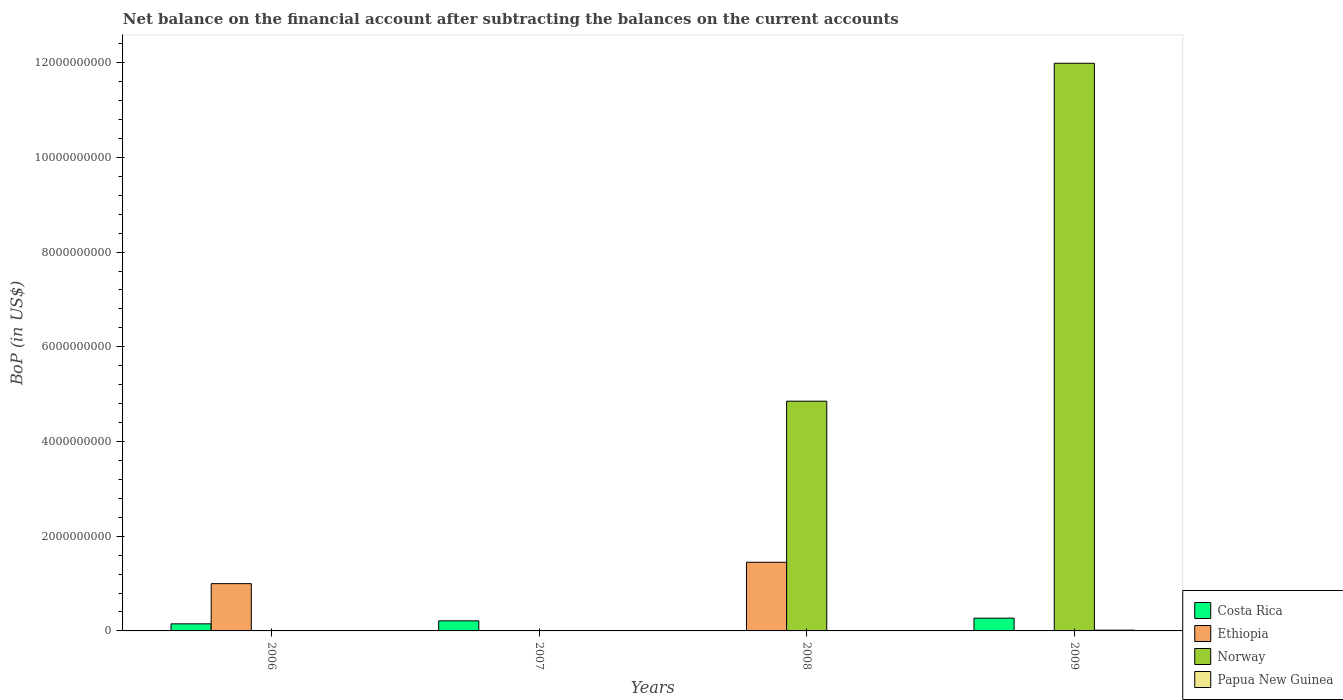Are the number of bars on each tick of the X-axis equal?
Ensure brevity in your answer.  No. How many bars are there on the 3rd tick from the left?
Provide a succinct answer. 2. What is the label of the 3rd group of bars from the left?
Ensure brevity in your answer.  2008. What is the Balance of Payments in Papua New Guinea in 2009?
Offer a terse response. 1.59e+07. Across all years, what is the maximum Balance of Payments in Costa Rica?
Make the answer very short. 2.69e+08. Across all years, what is the minimum Balance of Payments in Papua New Guinea?
Your response must be concise. 0. What is the total Balance of Payments in Norway in the graph?
Your answer should be compact. 1.68e+1. What is the difference between the Balance of Payments in Ethiopia in 2006 and that in 2008?
Your answer should be very brief. -4.52e+08. What is the difference between the Balance of Payments in Ethiopia in 2008 and the Balance of Payments in Papua New Guinea in 2007?
Provide a succinct answer. 1.44e+09. What is the average Balance of Payments in Costa Rica per year?
Offer a terse response. 1.58e+08. In the year 2009, what is the difference between the Balance of Payments in Papua New Guinea and Balance of Payments in Costa Rica?
Offer a terse response. -2.54e+08. What is the ratio of the Balance of Payments in Costa Rica in 2007 to that in 2009?
Provide a succinct answer. 0.79. What is the difference between the highest and the lowest Balance of Payments in Ethiopia?
Offer a terse response. 1.45e+09. Is it the case that in every year, the sum of the Balance of Payments in Papua New Guinea and Balance of Payments in Norway is greater than the sum of Balance of Payments in Ethiopia and Balance of Payments in Costa Rica?
Your response must be concise. No. Is it the case that in every year, the sum of the Balance of Payments in Costa Rica and Balance of Payments in Ethiopia is greater than the Balance of Payments in Norway?
Make the answer very short. No. How many bars are there?
Give a very brief answer. 9. What is the difference between two consecutive major ticks on the Y-axis?
Ensure brevity in your answer.  2.00e+09. Are the values on the major ticks of Y-axis written in scientific E-notation?
Your answer should be very brief. No. Where does the legend appear in the graph?
Make the answer very short. Bottom right. How many legend labels are there?
Make the answer very short. 4. What is the title of the graph?
Your answer should be very brief. Net balance on the financial account after subtracting the balances on the current accounts. Does "Kyrgyz Republic" appear as one of the legend labels in the graph?
Provide a short and direct response. No. What is the label or title of the X-axis?
Make the answer very short. Years. What is the label or title of the Y-axis?
Keep it short and to the point. BoP (in US$). What is the BoP (in US$) in Costa Rica in 2006?
Your answer should be very brief. 1.50e+08. What is the BoP (in US$) in Ethiopia in 2006?
Provide a short and direct response. 9.98e+08. What is the BoP (in US$) of Norway in 2006?
Your response must be concise. 0. What is the BoP (in US$) of Costa Rica in 2007?
Your response must be concise. 2.13e+08. What is the BoP (in US$) of Ethiopia in 2007?
Your answer should be compact. 0. What is the BoP (in US$) in Papua New Guinea in 2007?
Give a very brief answer. 9.00e+06. What is the BoP (in US$) of Costa Rica in 2008?
Your response must be concise. 0. What is the BoP (in US$) of Ethiopia in 2008?
Provide a short and direct response. 1.45e+09. What is the BoP (in US$) of Norway in 2008?
Your answer should be compact. 4.85e+09. What is the BoP (in US$) of Costa Rica in 2009?
Keep it short and to the point. 2.69e+08. What is the BoP (in US$) in Ethiopia in 2009?
Your answer should be compact. 0. What is the BoP (in US$) of Norway in 2009?
Your response must be concise. 1.20e+1. What is the BoP (in US$) in Papua New Guinea in 2009?
Make the answer very short. 1.59e+07. Across all years, what is the maximum BoP (in US$) of Costa Rica?
Your response must be concise. 2.69e+08. Across all years, what is the maximum BoP (in US$) in Ethiopia?
Offer a terse response. 1.45e+09. Across all years, what is the maximum BoP (in US$) in Norway?
Provide a short and direct response. 1.20e+1. Across all years, what is the maximum BoP (in US$) in Papua New Guinea?
Your answer should be very brief. 1.59e+07. Across all years, what is the minimum BoP (in US$) in Papua New Guinea?
Keep it short and to the point. 0. What is the total BoP (in US$) of Costa Rica in the graph?
Make the answer very short. 6.32e+08. What is the total BoP (in US$) of Ethiopia in the graph?
Keep it short and to the point. 2.45e+09. What is the total BoP (in US$) of Norway in the graph?
Give a very brief answer. 1.68e+1. What is the total BoP (in US$) of Papua New Guinea in the graph?
Your answer should be very brief. 2.49e+07. What is the difference between the BoP (in US$) of Costa Rica in 2006 and that in 2007?
Provide a succinct answer. -6.34e+07. What is the difference between the BoP (in US$) in Ethiopia in 2006 and that in 2008?
Keep it short and to the point. -4.52e+08. What is the difference between the BoP (in US$) of Costa Rica in 2006 and that in 2009?
Make the answer very short. -1.20e+08. What is the difference between the BoP (in US$) of Costa Rica in 2007 and that in 2009?
Your response must be concise. -5.64e+07. What is the difference between the BoP (in US$) of Papua New Guinea in 2007 and that in 2009?
Offer a terse response. -6.86e+06. What is the difference between the BoP (in US$) in Norway in 2008 and that in 2009?
Offer a terse response. -7.14e+09. What is the difference between the BoP (in US$) of Costa Rica in 2006 and the BoP (in US$) of Papua New Guinea in 2007?
Keep it short and to the point. 1.41e+08. What is the difference between the BoP (in US$) of Ethiopia in 2006 and the BoP (in US$) of Papua New Guinea in 2007?
Provide a succinct answer. 9.89e+08. What is the difference between the BoP (in US$) of Costa Rica in 2006 and the BoP (in US$) of Ethiopia in 2008?
Provide a short and direct response. -1.30e+09. What is the difference between the BoP (in US$) of Costa Rica in 2006 and the BoP (in US$) of Norway in 2008?
Offer a very short reply. -4.70e+09. What is the difference between the BoP (in US$) in Ethiopia in 2006 and the BoP (in US$) in Norway in 2008?
Offer a terse response. -3.85e+09. What is the difference between the BoP (in US$) of Costa Rica in 2006 and the BoP (in US$) of Norway in 2009?
Offer a very short reply. -1.18e+1. What is the difference between the BoP (in US$) in Costa Rica in 2006 and the BoP (in US$) in Papua New Guinea in 2009?
Your answer should be very brief. 1.34e+08. What is the difference between the BoP (in US$) in Ethiopia in 2006 and the BoP (in US$) in Norway in 2009?
Provide a short and direct response. -1.10e+1. What is the difference between the BoP (in US$) of Ethiopia in 2006 and the BoP (in US$) of Papua New Guinea in 2009?
Your answer should be very brief. 9.82e+08. What is the difference between the BoP (in US$) of Costa Rica in 2007 and the BoP (in US$) of Ethiopia in 2008?
Offer a terse response. -1.24e+09. What is the difference between the BoP (in US$) in Costa Rica in 2007 and the BoP (in US$) in Norway in 2008?
Your response must be concise. -4.64e+09. What is the difference between the BoP (in US$) in Costa Rica in 2007 and the BoP (in US$) in Norway in 2009?
Make the answer very short. -1.18e+1. What is the difference between the BoP (in US$) in Costa Rica in 2007 and the BoP (in US$) in Papua New Guinea in 2009?
Offer a very short reply. 1.97e+08. What is the difference between the BoP (in US$) in Ethiopia in 2008 and the BoP (in US$) in Norway in 2009?
Give a very brief answer. -1.05e+1. What is the difference between the BoP (in US$) in Ethiopia in 2008 and the BoP (in US$) in Papua New Guinea in 2009?
Provide a succinct answer. 1.43e+09. What is the difference between the BoP (in US$) in Norway in 2008 and the BoP (in US$) in Papua New Guinea in 2009?
Give a very brief answer. 4.84e+09. What is the average BoP (in US$) of Costa Rica per year?
Ensure brevity in your answer.  1.58e+08. What is the average BoP (in US$) of Ethiopia per year?
Provide a succinct answer. 6.12e+08. What is the average BoP (in US$) of Norway per year?
Provide a succinct answer. 4.21e+09. What is the average BoP (in US$) of Papua New Guinea per year?
Provide a short and direct response. 6.22e+06. In the year 2006, what is the difference between the BoP (in US$) in Costa Rica and BoP (in US$) in Ethiopia?
Provide a succinct answer. -8.49e+08. In the year 2007, what is the difference between the BoP (in US$) of Costa Rica and BoP (in US$) of Papua New Guinea?
Ensure brevity in your answer.  2.04e+08. In the year 2008, what is the difference between the BoP (in US$) in Ethiopia and BoP (in US$) in Norway?
Your answer should be very brief. -3.40e+09. In the year 2009, what is the difference between the BoP (in US$) in Costa Rica and BoP (in US$) in Norway?
Give a very brief answer. -1.17e+1. In the year 2009, what is the difference between the BoP (in US$) of Costa Rica and BoP (in US$) of Papua New Guinea?
Give a very brief answer. 2.54e+08. In the year 2009, what is the difference between the BoP (in US$) in Norway and BoP (in US$) in Papua New Guinea?
Offer a terse response. 1.20e+1. What is the ratio of the BoP (in US$) in Costa Rica in 2006 to that in 2007?
Your answer should be very brief. 0.7. What is the ratio of the BoP (in US$) in Ethiopia in 2006 to that in 2008?
Your response must be concise. 0.69. What is the ratio of the BoP (in US$) of Costa Rica in 2006 to that in 2009?
Give a very brief answer. 0.56. What is the ratio of the BoP (in US$) in Costa Rica in 2007 to that in 2009?
Give a very brief answer. 0.79. What is the ratio of the BoP (in US$) of Papua New Guinea in 2007 to that in 2009?
Keep it short and to the point. 0.57. What is the ratio of the BoP (in US$) in Norway in 2008 to that in 2009?
Your answer should be very brief. 0.4. What is the difference between the highest and the second highest BoP (in US$) in Costa Rica?
Your answer should be compact. 5.64e+07. What is the difference between the highest and the lowest BoP (in US$) in Costa Rica?
Provide a succinct answer. 2.69e+08. What is the difference between the highest and the lowest BoP (in US$) in Ethiopia?
Give a very brief answer. 1.45e+09. What is the difference between the highest and the lowest BoP (in US$) of Norway?
Make the answer very short. 1.20e+1. What is the difference between the highest and the lowest BoP (in US$) of Papua New Guinea?
Provide a short and direct response. 1.59e+07. 